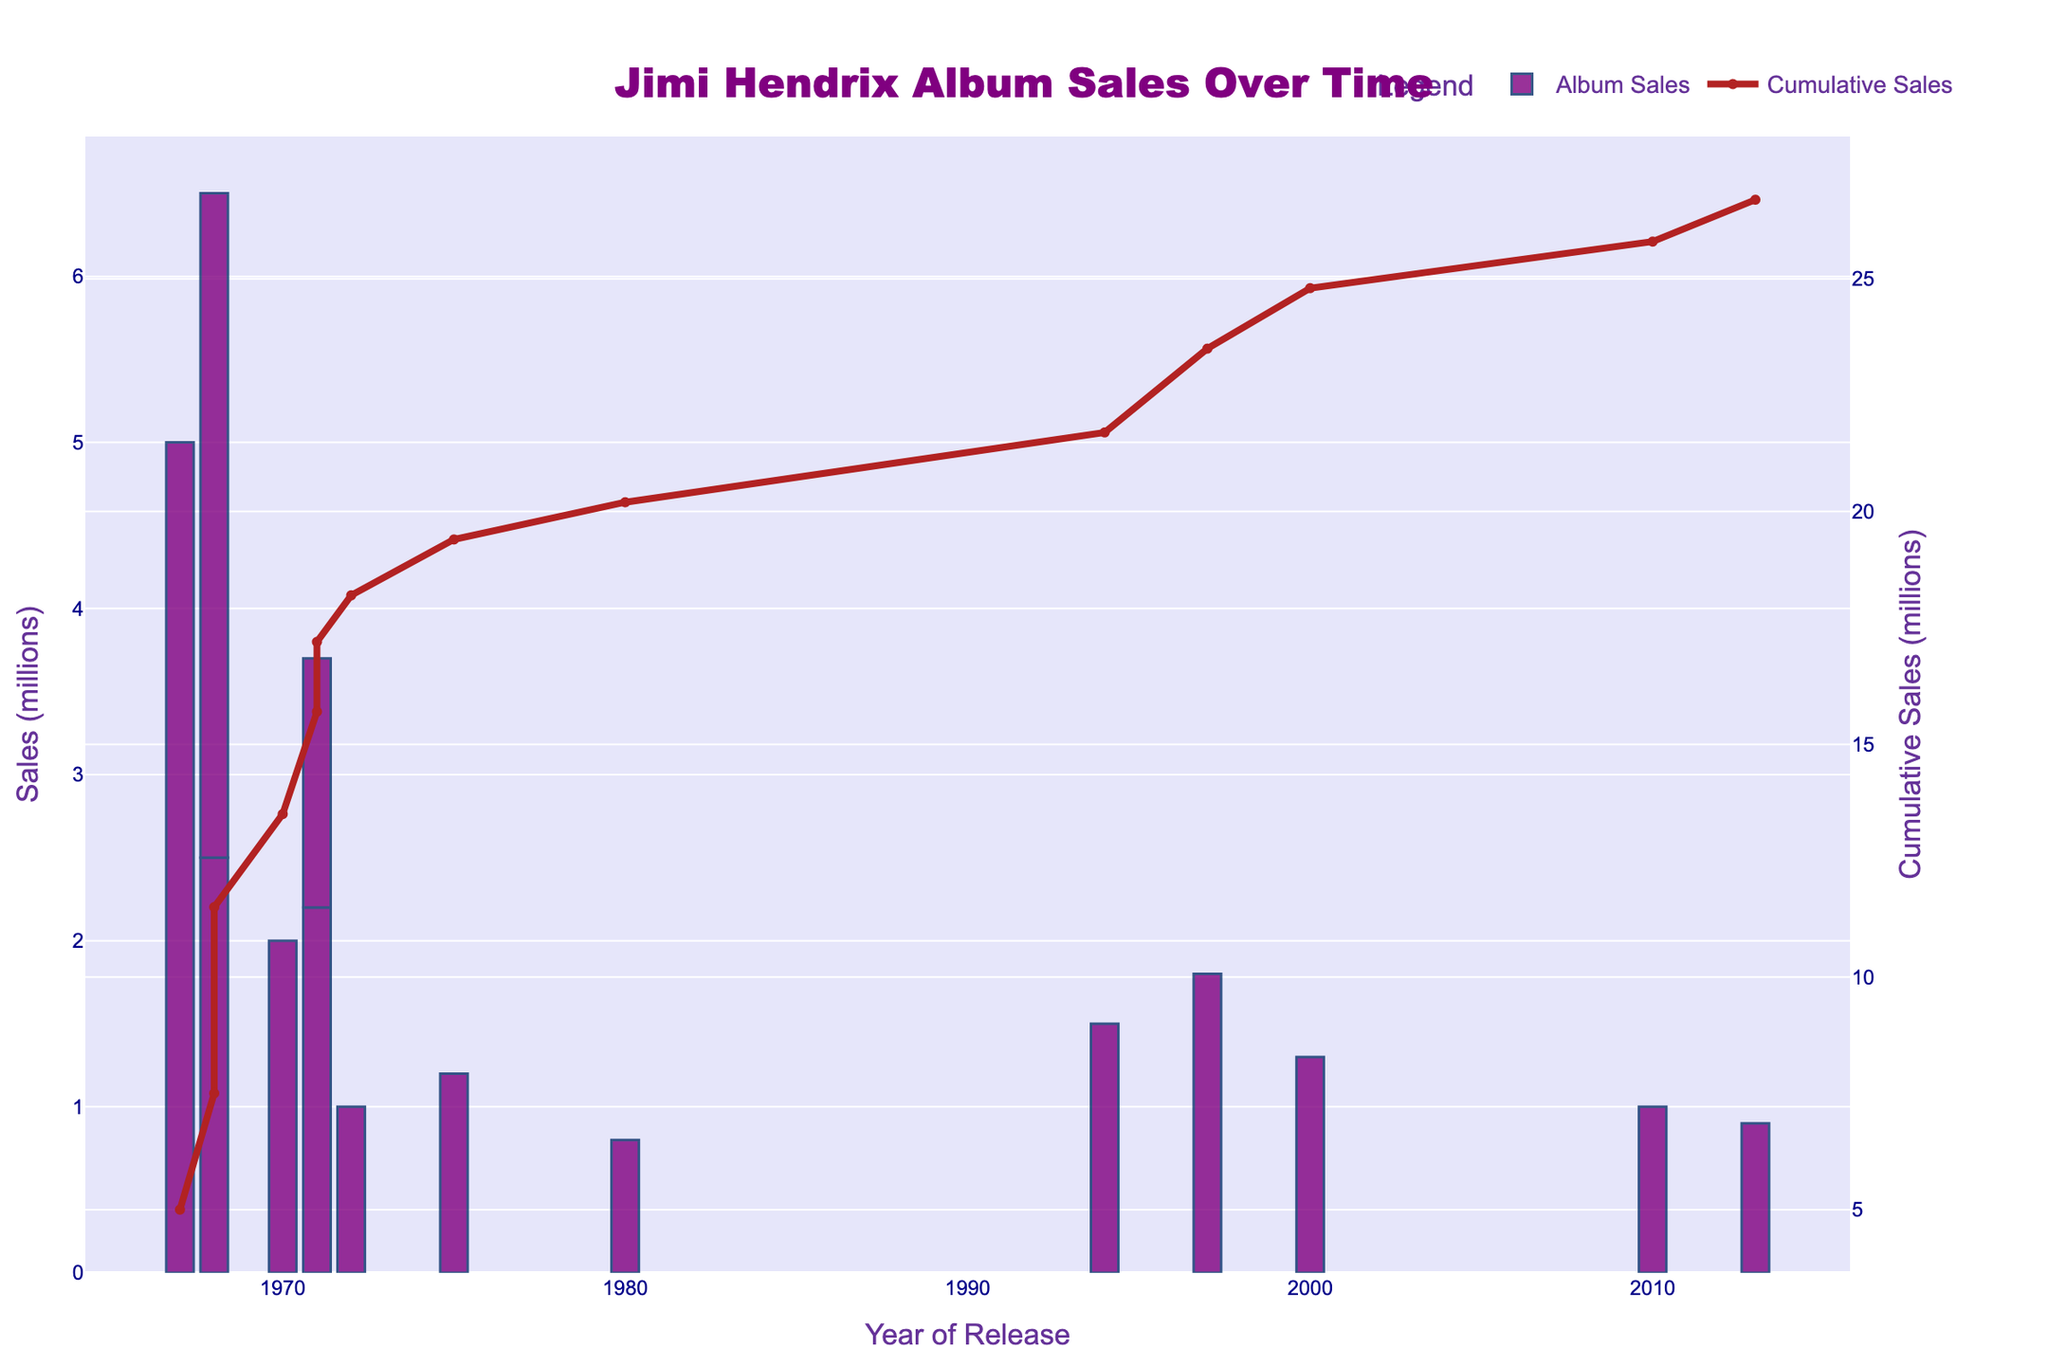Which album has the highest sales, and what is its sales figure? The highest bar represents "Are You Experienced" which was released in 1967, and the height indicates sales of 5.0 million.
Answer: "Are You Experienced", 5.0 million How does the cumulative sales trend look over time? The red line indicates cumulative sales, and it shows a generally increasing trend over time, with relatively sharp rises around 1967, 1968, and 1970, followed by smaller incremental increases in later years.
Answer: Increasing Which album released in 1971 has higher sales and by how much? In 1971, two albums "The Cry of Love" and "Rainbow Bridge" were released. "The Cry of Love" has sales of 2.2 million while "Rainbow Bridge" has 1.5 million. The difference is 2.2 - 1.5 = 0.7 million.
Answer: "The Cry of Love" by 0.7 million What is the total sales figure for albums released in the 1960s? Summing up the sales for albums released in 1967 and 1968: 5.0 + 2.5 + 4.0 = 11.5 million
Answer: 11.5 million Which album has the lowest sales, and what is its sales figure? The shortest bar represents "Nine to the Universe" which was released in 1980, and the height indicates sales of 0.8 million.
Answer: "Nine to the Universe", 0.8 million What is the average sales figure for albums released after 1990? The albums released after 1990 are "Blues" (1.5 million), "First Rays of the New Rising Sun" (1.8 million), "The Jimi Hendrix Experience" (1.3 million), "Valleys of Neptune" (1.0 million), and "People Hell and Angels" (0.9 million). The sum of sales is 1.5 + 1.8 + 1.3 + 1.0 + 0.9 = 6.5 million, and there are 5 albums. Thus, the average is 6.5 / 5 = 1.3 million.
Answer: 1.3 million How much higher are the sales for "Electric Ladyland" compared to "Axis: Bold as Love"? "Electric Ladyland" has sales of 4.0 million, and "Axis: Bold as Love" has sales of 2.5 million. The difference is 4.0 - 2.5 = 1.5 million.
Answer: 1.5 million Which year had the highest cumulative sales increase, and how much was the increase? The cumulative sales plotted in the red line shows the sharpest increase between 1967 and 1968. The sales went from 5.0 million to 11.5 million. Therefore, the increase is 11.5 - 5.0 = 6.5 million.
Answer: 1968, 6.5 million What is the total cumulative sales at the end of the graph? The cumulative sales line ends at approximately 25 million, which is the total cumulative sales combining all albums from the start to the end.
Answer: 25 million 